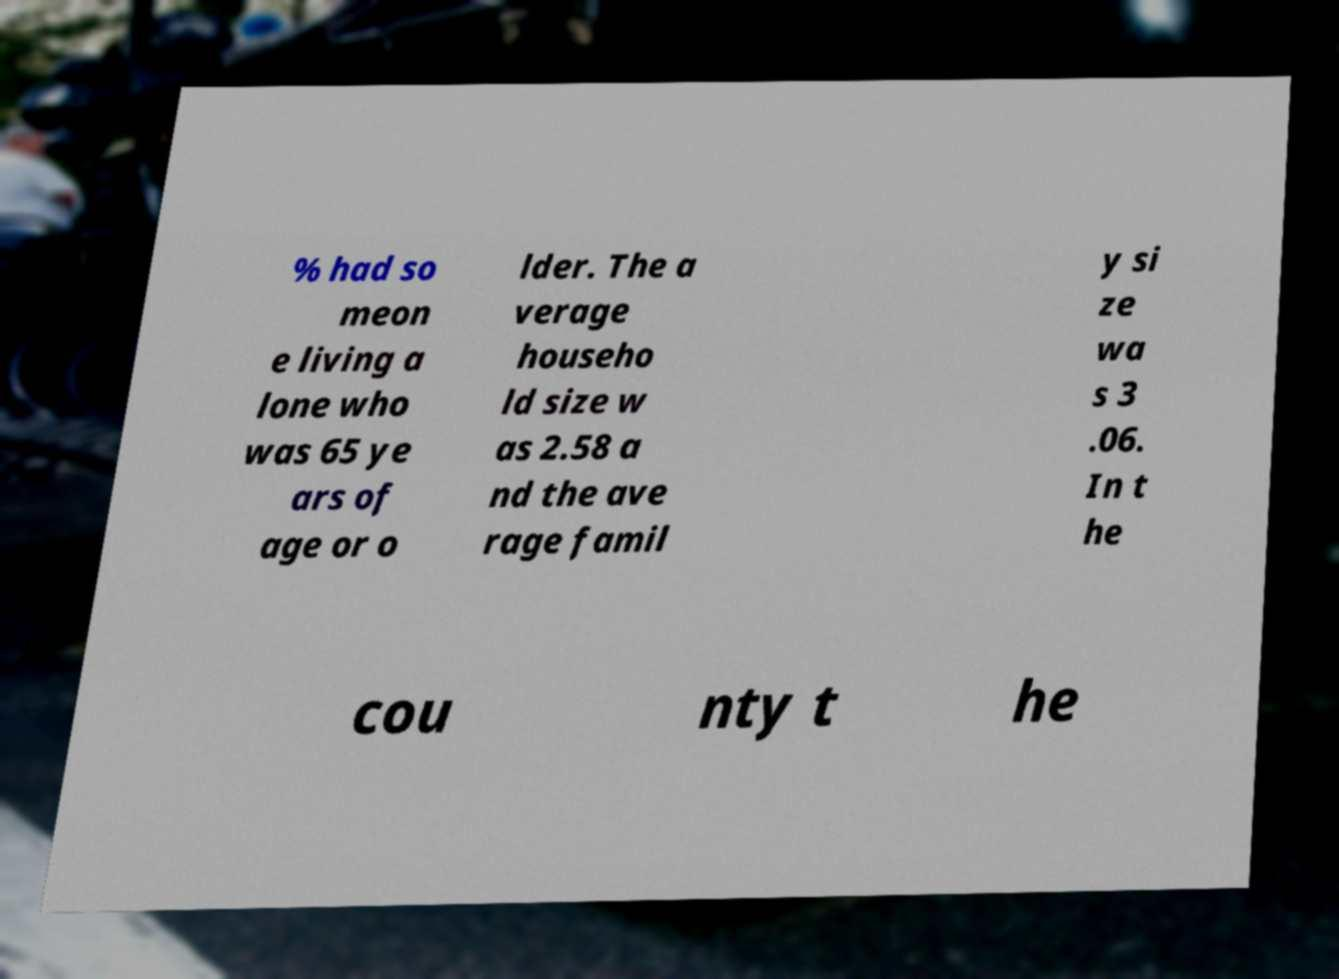Please identify and transcribe the text found in this image. % had so meon e living a lone who was 65 ye ars of age or o lder. The a verage househo ld size w as 2.58 a nd the ave rage famil y si ze wa s 3 .06. In t he cou nty t he 